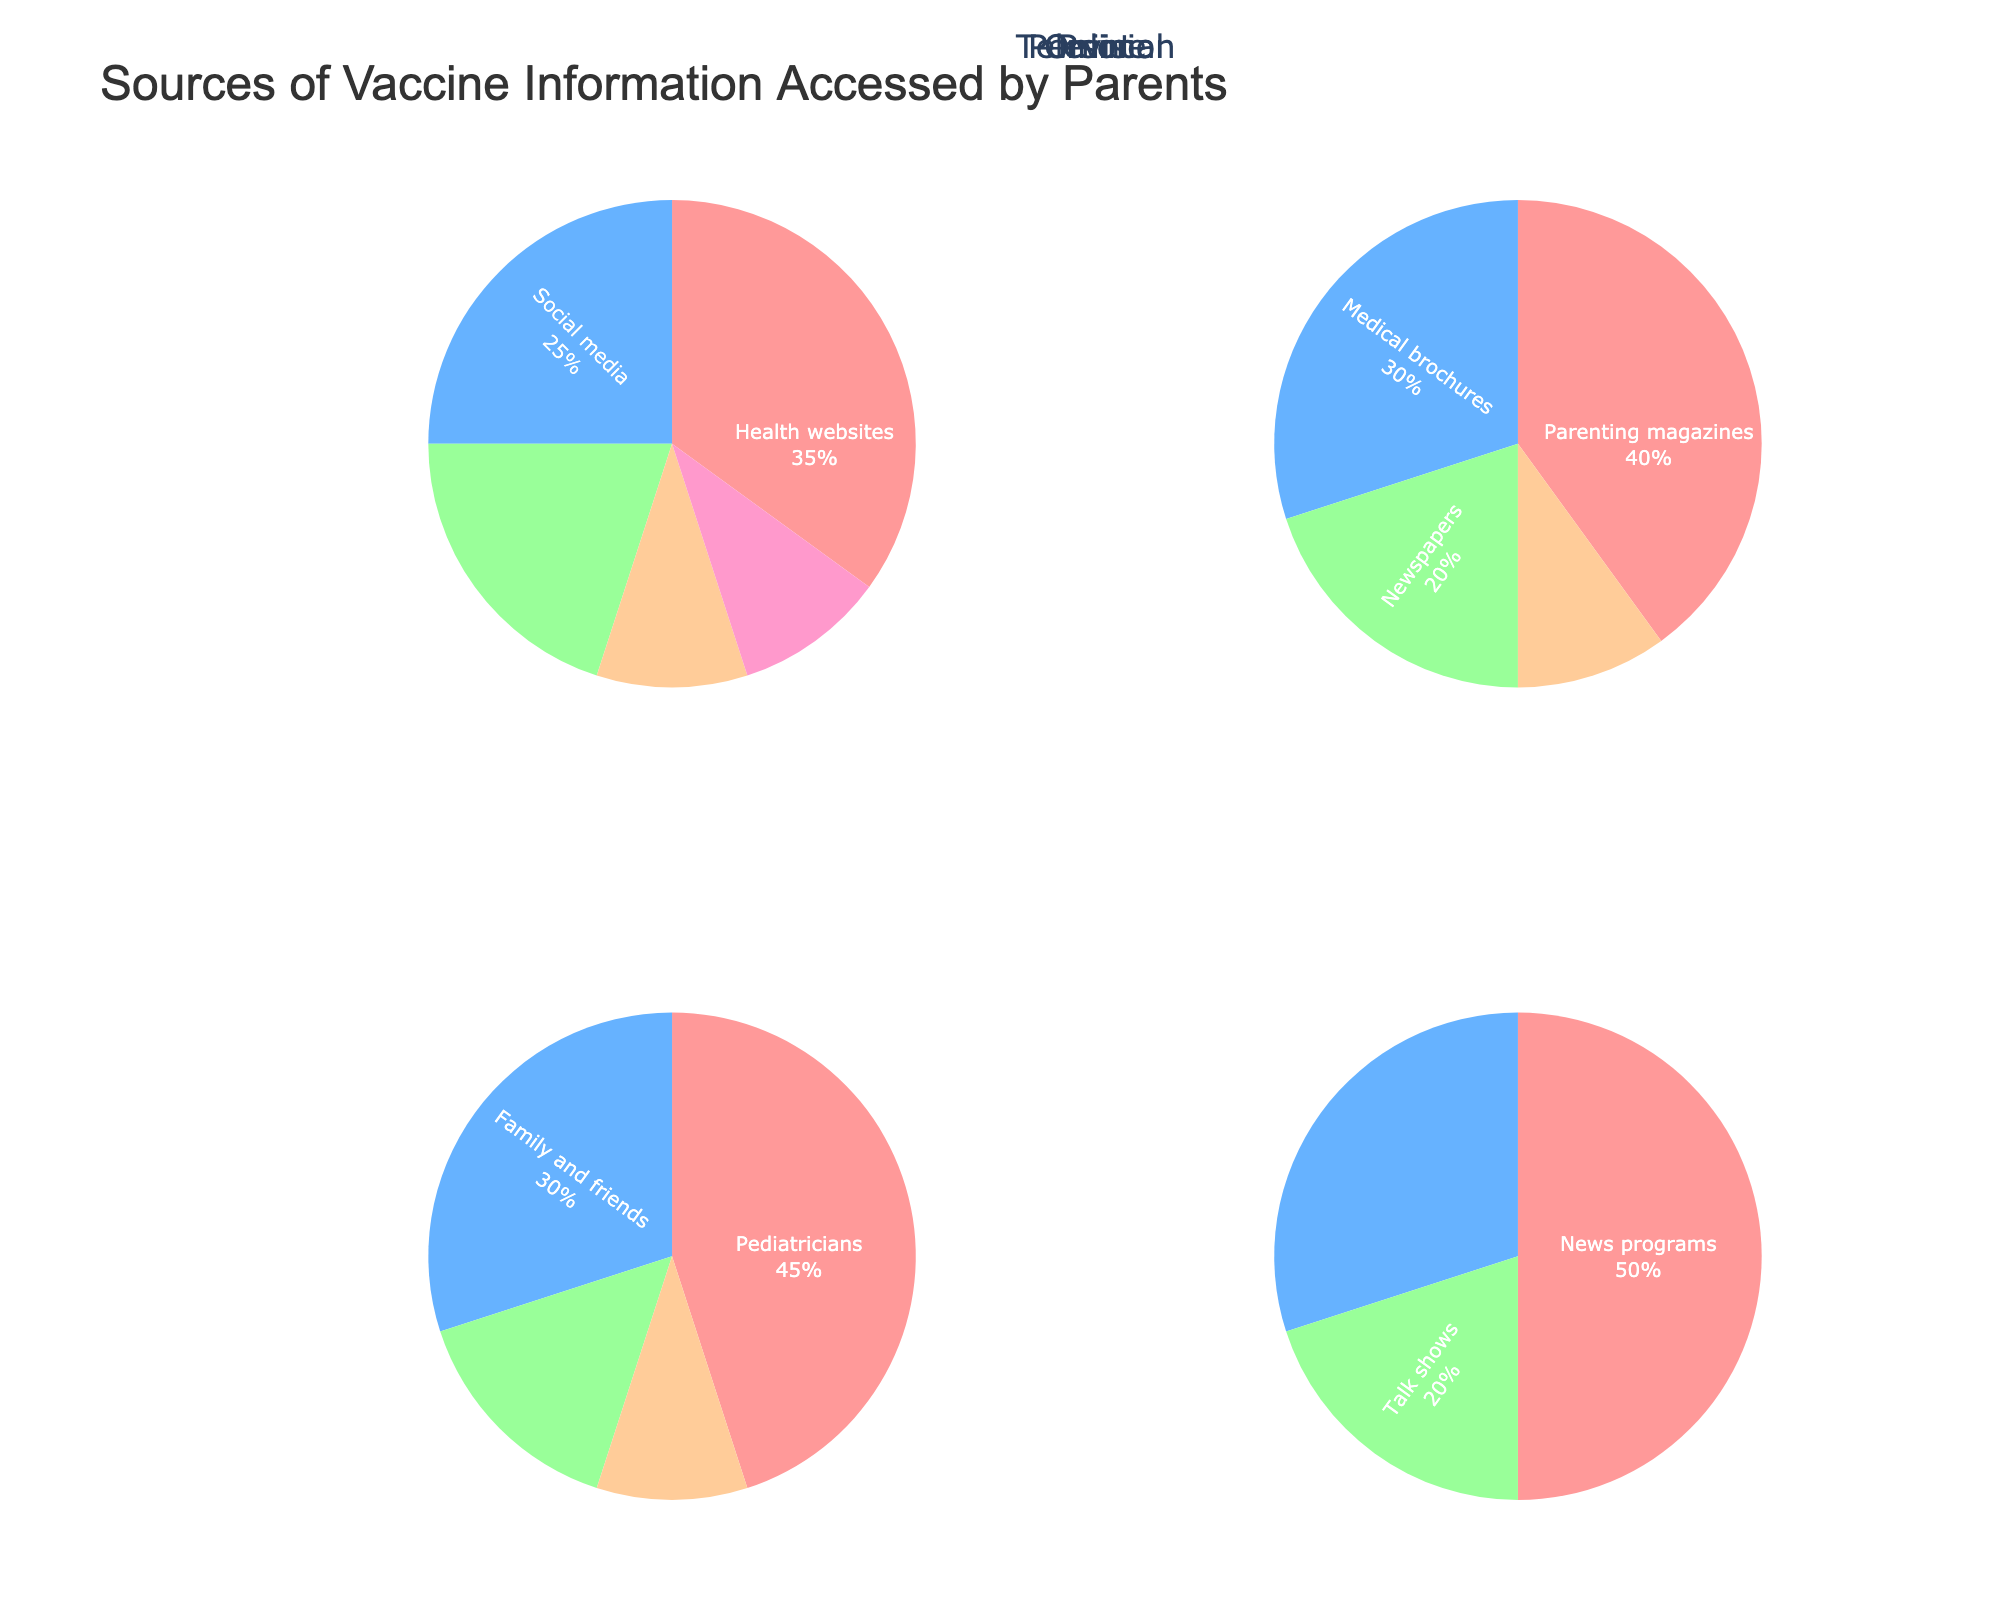what is the title of the figure? The title of the figure is located at the top of the plot and describes the main subject. In this case, it is "Sources of Vaccine Information Accessed by Parents".
Answer: Sources of Vaccine Information Accessed by Parents What does the largest segment in the "Television" pie chart represent? The "Television" pie chart has different segments representing different sources. The largest segment is represented by the longest arc that covers half of the circle, indicating "News programs" with 50%.
Answer: News programs Which medium has "Parenting magazines" as a source? By examining the labels of the different pie charts, you will find that "Parenting magazines" appear in the "Print" pie chart.
Answer: Print How does the percentage of "Pediatricians" as a source compare to "Family and friends" in the "Personal" medium? In the "Personal" medium, the percentage for "Pediatricians" is 45% while "Family and friends" account for 30%. Therefore, "Pediatricians" have a higher percentage than "Family and friends".
Answer: Pediatricians have a higher percentage What is the combined percentage of "Medical documentaries" and "Talk shows" in the "Television" medium? In the "Television" medium, "Medical documentaries" have a percentage of 30% and "Talk shows" have 20%. Adding these percentages together, we get 30% + 20% = 50%.
Answer: 50% Which source in the "Online" medium has the lowest percentage? Within the "Online" medium, each segment represents a different source with its respective percentage. "Parenting blogs" and "Medical journals" both have the lowest percentage, which is 10%.
Answer: Parenting blogs and Medical journals Is the percentage of "Scientific journals" in "Print" higher or lower than "Government websites" in "Online"? The percentage of "Scientific journals" in the "Print" medium is 10%, while "Government websites" in the "Online" medium have a percentage of 20%. Therefore, "Scientific journals" have a lower percentage than "Government websites".
Answer: Lower What is the smallest segment in the "Personal" pie chart and what percentage does it represent? In the "Personal" pie chart, the smallest segment can be identified by its smallest portion of the circle. It represents "Support groups" with a percentage of 10%.
Answer: Support groups, 10% 